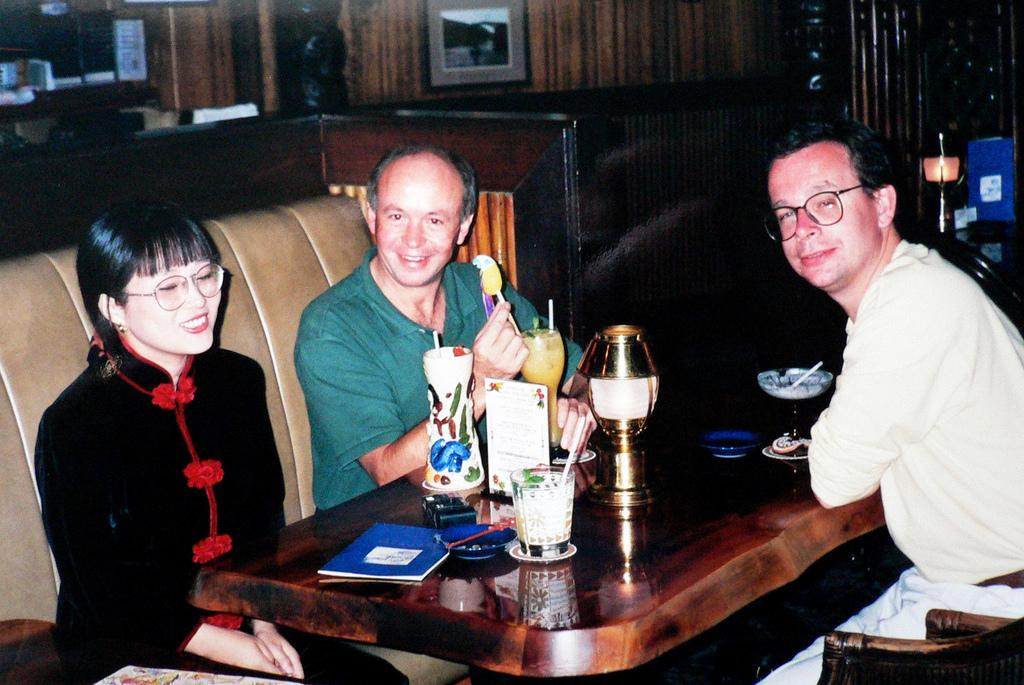How many people are in the image? There are three people in the image. What are the people doing in the image? The people are sitting on sofas. How are the sofas arranged in the image? The sofas are arranged around a table. What can be found on the table in the image? There are items on the table. What type of birds can be seen flying over the people in the image? There are no birds visible in the image. 